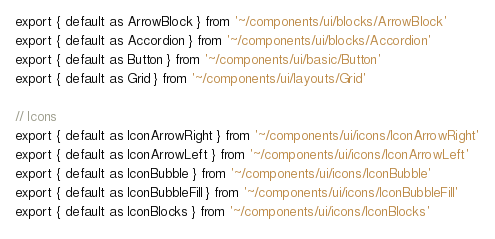Convert code to text. <code><loc_0><loc_0><loc_500><loc_500><_JavaScript_>export { default as ArrowBlock } from '~/components/ui/blocks/ArrowBlock'
export { default as Accordion } from '~/components/ui/blocks/Accordion'
export { default as Button } from '~/components/ui/basic/Button'
export { default as Grid } from '~/components/ui/layouts/Grid'

// Icons
export { default as IconArrowRight } from '~/components/ui/icons/IconArrowRight'
export { default as IconArrowLeft } from '~/components/ui/icons/IconArrowLeft'
export { default as IconBubble } from '~/components/ui/icons/IconBubble'
export { default as IconBubbleFill } from '~/components/ui/icons/IconBubbleFill'
export { default as IconBlocks } from '~/components/ui/icons/IconBlocks'
</code> 